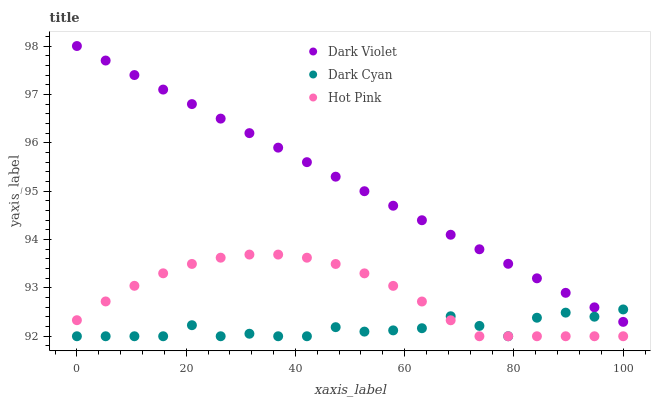Does Dark Cyan have the minimum area under the curve?
Answer yes or no. Yes. Does Dark Violet have the maximum area under the curve?
Answer yes or no. Yes. Does Hot Pink have the minimum area under the curve?
Answer yes or no. No. Does Hot Pink have the maximum area under the curve?
Answer yes or no. No. Is Dark Violet the smoothest?
Answer yes or no. Yes. Is Dark Cyan the roughest?
Answer yes or no. Yes. Is Hot Pink the smoothest?
Answer yes or no. No. Is Hot Pink the roughest?
Answer yes or no. No. Does Dark Cyan have the lowest value?
Answer yes or no. Yes. Does Dark Violet have the lowest value?
Answer yes or no. No. Does Dark Violet have the highest value?
Answer yes or no. Yes. Does Hot Pink have the highest value?
Answer yes or no. No. Is Hot Pink less than Dark Violet?
Answer yes or no. Yes. Is Dark Violet greater than Hot Pink?
Answer yes or no. Yes. Does Dark Cyan intersect Dark Violet?
Answer yes or no. Yes. Is Dark Cyan less than Dark Violet?
Answer yes or no. No. Is Dark Cyan greater than Dark Violet?
Answer yes or no. No. Does Hot Pink intersect Dark Violet?
Answer yes or no. No. 